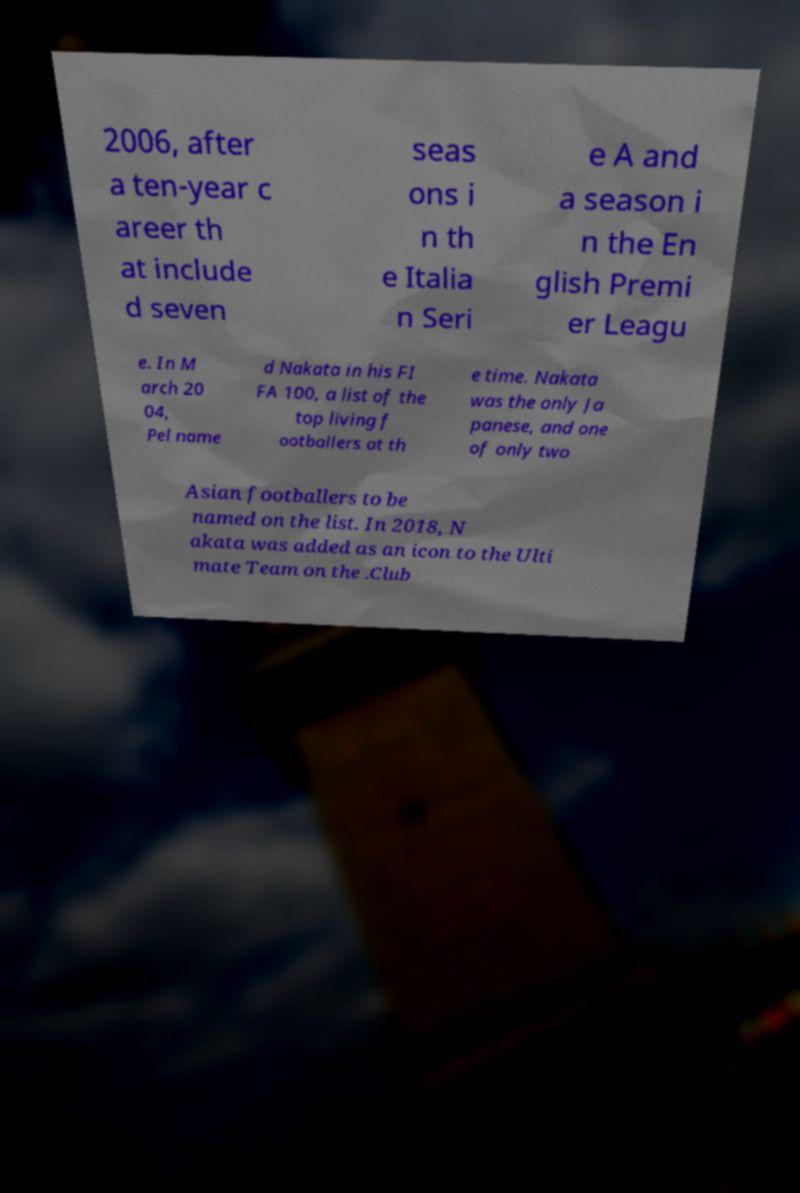Could you assist in decoding the text presented in this image and type it out clearly? 2006, after a ten-year c areer th at include d seven seas ons i n th e Italia n Seri e A and a season i n the En glish Premi er Leagu e. In M arch 20 04, Pel name d Nakata in his FI FA 100, a list of the top living f ootballers at th e time. Nakata was the only Ja panese, and one of only two Asian footballers to be named on the list. In 2018, N akata was added as an icon to the Ulti mate Team on the .Club 